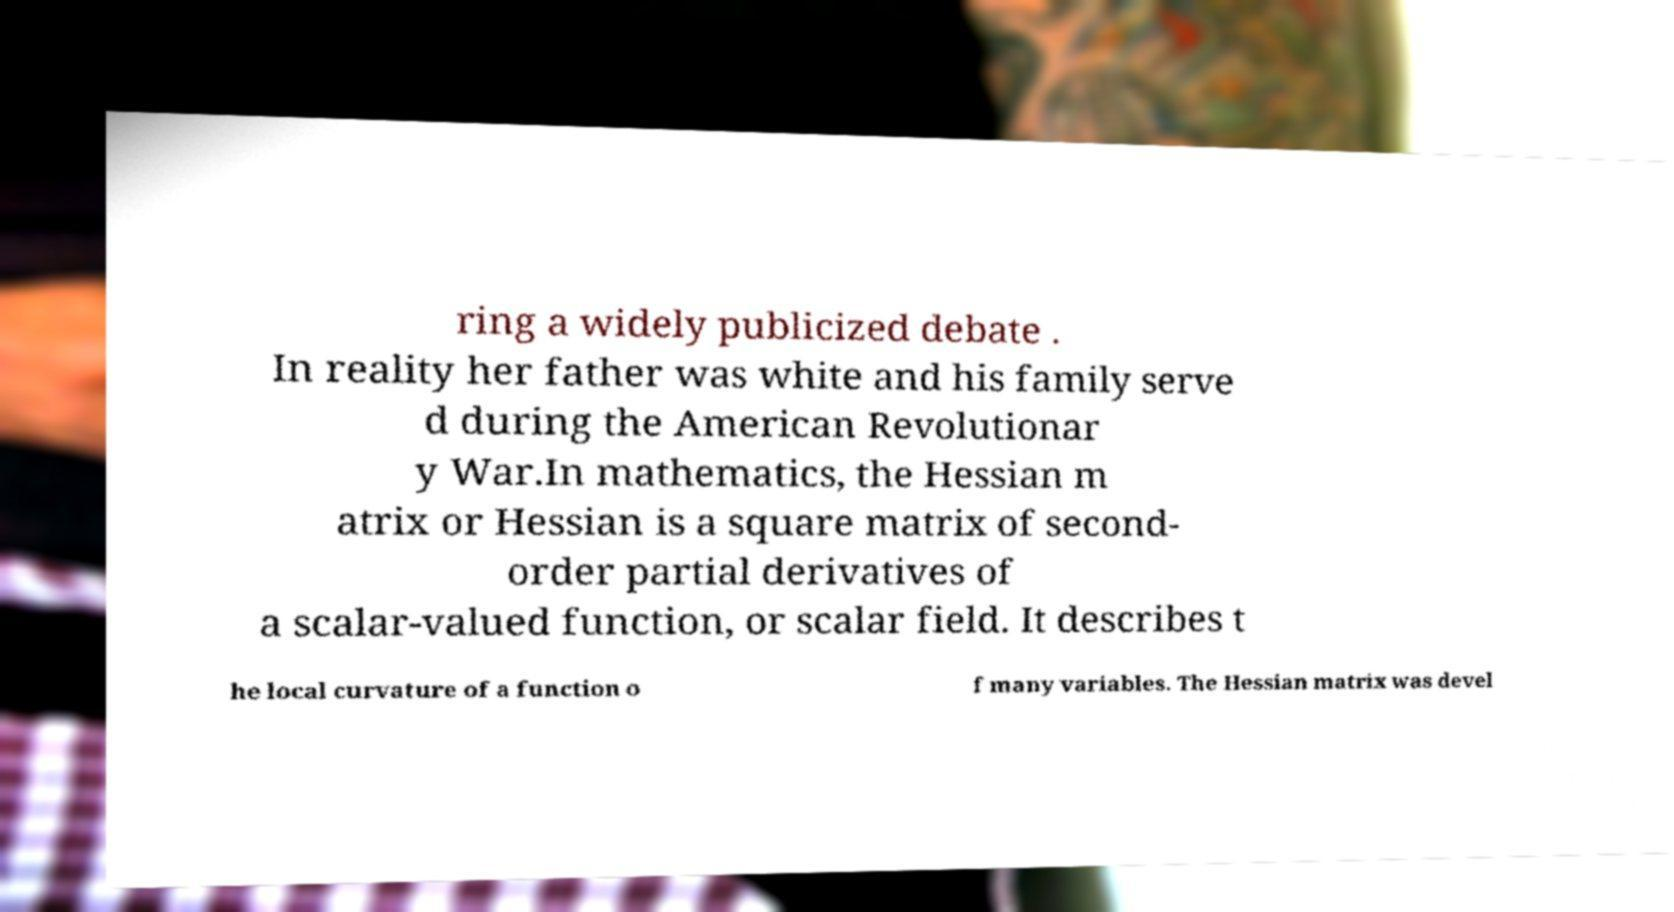For documentation purposes, I need the text within this image transcribed. Could you provide that? ring a widely publicized debate . In reality her father was white and his family serve d during the American Revolutionar y War.In mathematics, the Hessian m atrix or Hessian is a square matrix of second- order partial derivatives of a scalar-valued function, or scalar field. It describes t he local curvature of a function o f many variables. The Hessian matrix was devel 